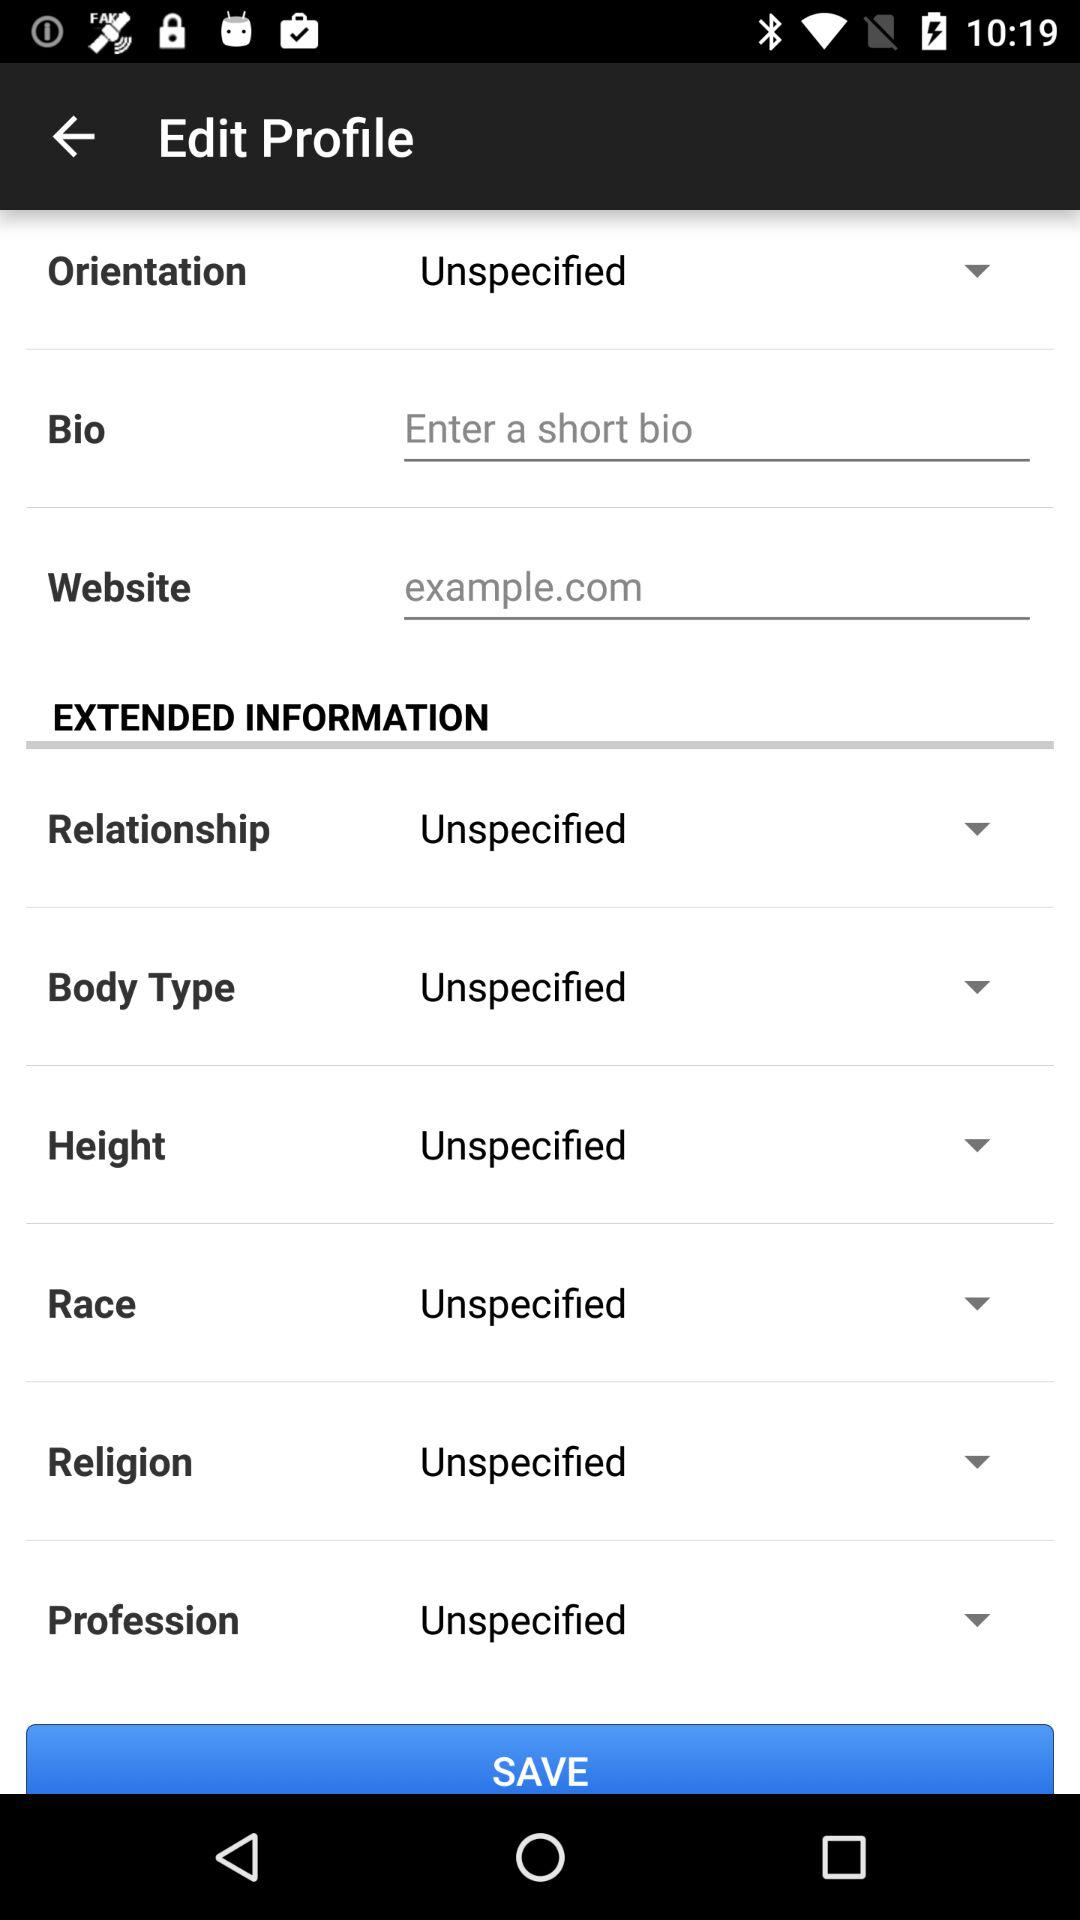What is the setting for height? The setting is "Unspecified". 